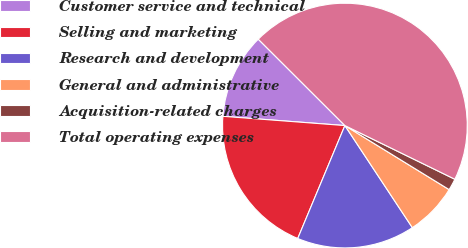Convert chart to OTSL. <chart><loc_0><loc_0><loc_500><loc_500><pie_chart><fcel>Customer service and technical<fcel>Selling and marketing<fcel>Research and development<fcel>General and administrative<fcel>Acquisition-related charges<fcel>Total operating expenses<nl><fcel>11.27%<fcel>19.91%<fcel>15.59%<fcel>6.94%<fcel>1.54%<fcel>44.75%<nl></chart> 